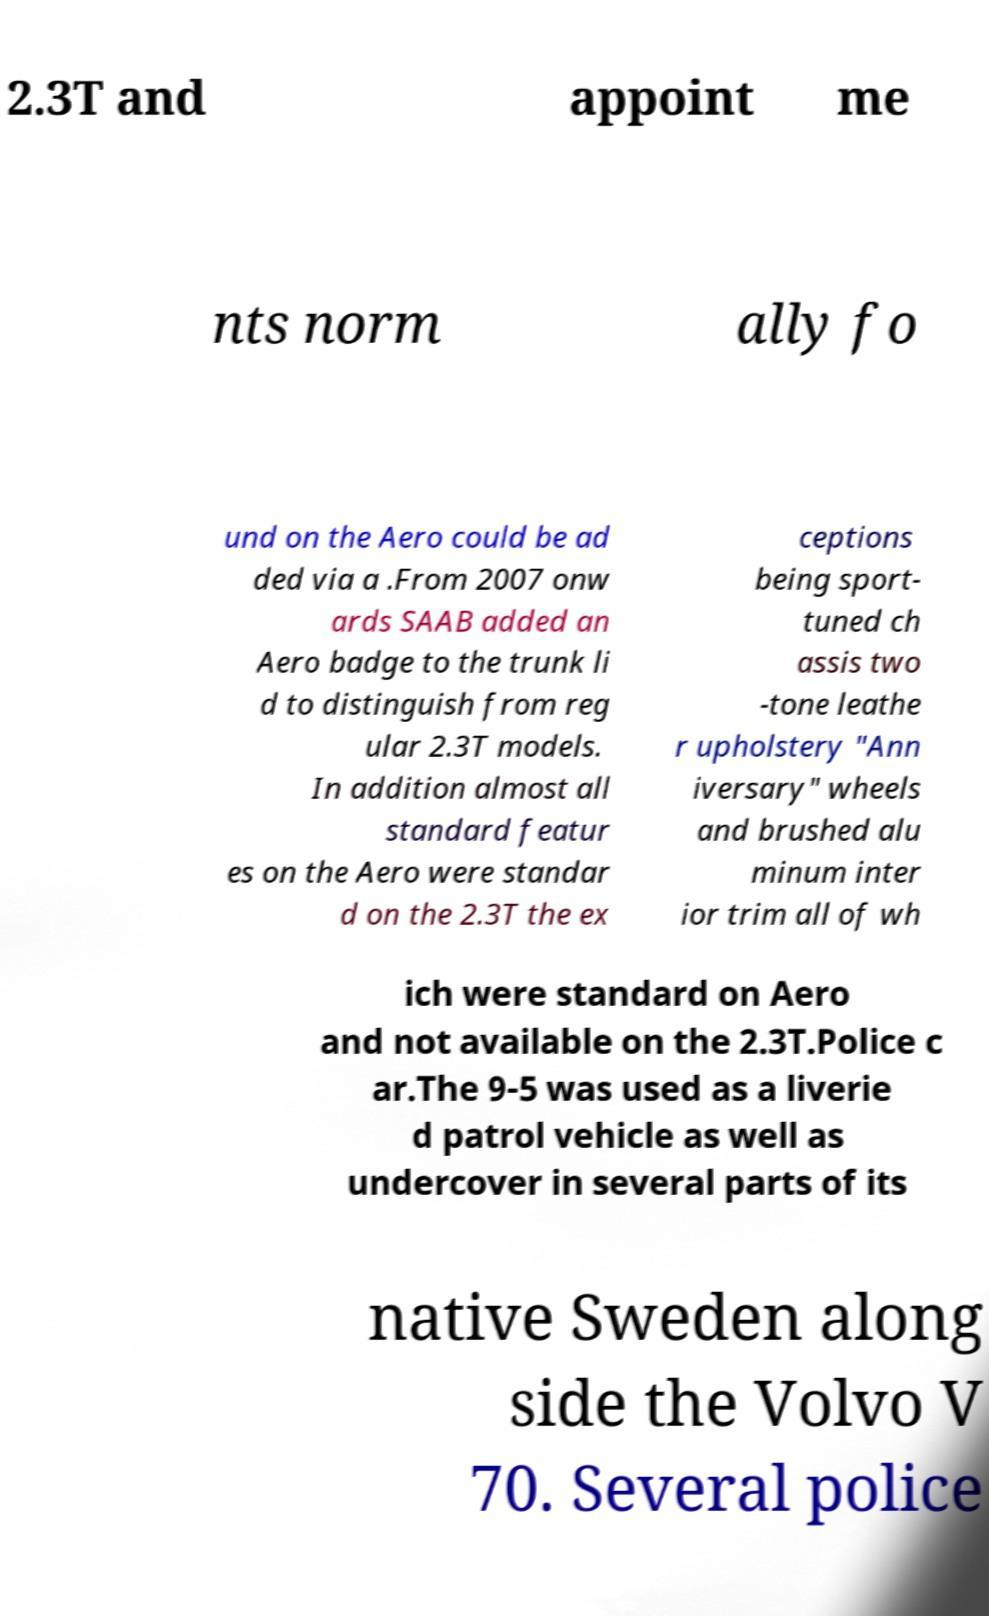Could you extract and type out the text from this image? 2.3T and appoint me nts norm ally fo und on the Aero could be ad ded via a .From 2007 onw ards SAAB added an Aero badge to the trunk li d to distinguish from reg ular 2.3T models. In addition almost all standard featur es on the Aero were standar d on the 2.3T the ex ceptions being sport- tuned ch assis two -tone leathe r upholstery "Ann iversary" wheels and brushed alu minum inter ior trim all of wh ich were standard on Aero and not available on the 2.3T.Police c ar.The 9-5 was used as a liverie d patrol vehicle as well as undercover in several parts of its native Sweden along side the Volvo V 70. Several police 